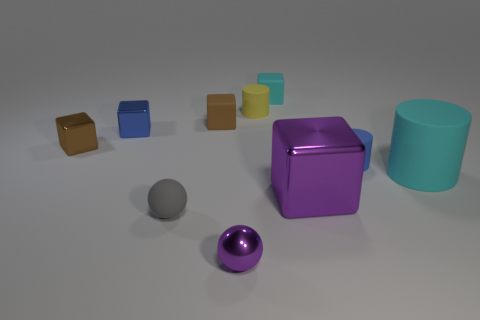The purple thing that is the same shape as the tiny gray object is what size? The purple object, which shares its spherical shape with the small gray object, appears to be of a small size as well, although slightly larger due to perspective and closer proximity to the viewpoint. 